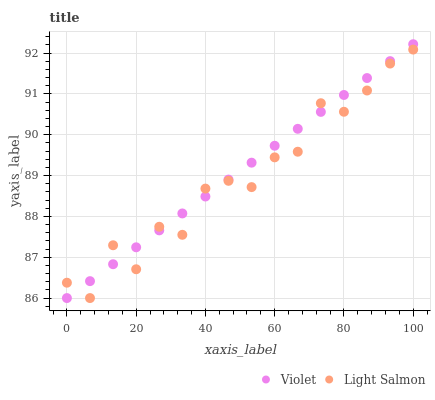Does Light Salmon have the minimum area under the curve?
Answer yes or no. Yes. Does Violet have the maximum area under the curve?
Answer yes or no. Yes. Does Violet have the minimum area under the curve?
Answer yes or no. No. Is Violet the smoothest?
Answer yes or no. Yes. Is Light Salmon the roughest?
Answer yes or no. Yes. Is Violet the roughest?
Answer yes or no. No. Does Light Salmon have the lowest value?
Answer yes or no. Yes. Does Violet have the highest value?
Answer yes or no. Yes. Does Light Salmon intersect Violet?
Answer yes or no. Yes. Is Light Salmon less than Violet?
Answer yes or no. No. Is Light Salmon greater than Violet?
Answer yes or no. No. 